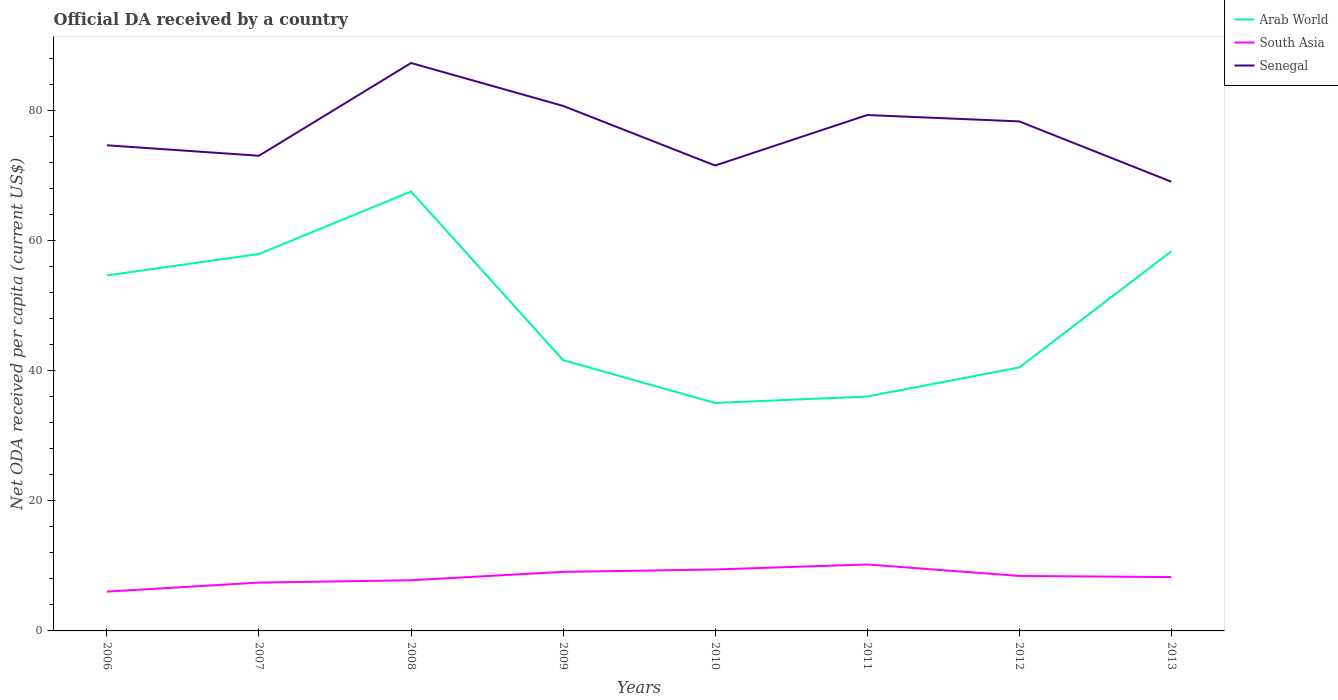How many different coloured lines are there?
Give a very brief answer. 3. Does the line corresponding to Senegal intersect with the line corresponding to Arab World?
Your answer should be compact. No. Across all years, what is the maximum ODA received in in Senegal?
Provide a succinct answer. 69.11. In which year was the ODA received in in Senegal maximum?
Keep it short and to the point. 2013. What is the total ODA received in in South Asia in the graph?
Ensure brevity in your answer.  -3.04. What is the difference between the highest and the second highest ODA received in in Arab World?
Make the answer very short. 32.53. Is the ODA received in in Arab World strictly greater than the ODA received in in South Asia over the years?
Provide a short and direct response. No. How many lines are there?
Your answer should be very brief. 3. How many years are there in the graph?
Offer a very short reply. 8. What is the difference between two consecutive major ticks on the Y-axis?
Offer a very short reply. 20. Does the graph contain grids?
Ensure brevity in your answer.  No. Where does the legend appear in the graph?
Keep it short and to the point. Top right. How many legend labels are there?
Your response must be concise. 3. What is the title of the graph?
Provide a short and direct response. Official DA received by a country. Does "Morocco" appear as one of the legend labels in the graph?
Your answer should be very brief. No. What is the label or title of the Y-axis?
Give a very brief answer. Net ODA received per capita (current US$). What is the Net ODA received per capita (current US$) in Arab World in 2006?
Give a very brief answer. 54.7. What is the Net ODA received per capita (current US$) in South Asia in 2006?
Your answer should be very brief. 6.05. What is the Net ODA received per capita (current US$) of Senegal in 2006?
Your answer should be very brief. 74.71. What is the Net ODA received per capita (current US$) of Arab World in 2007?
Provide a short and direct response. 57.98. What is the Net ODA received per capita (current US$) in South Asia in 2007?
Give a very brief answer. 7.43. What is the Net ODA received per capita (current US$) in Senegal in 2007?
Offer a very short reply. 73.1. What is the Net ODA received per capita (current US$) in Arab World in 2008?
Your answer should be very brief. 67.6. What is the Net ODA received per capita (current US$) of South Asia in 2008?
Make the answer very short. 7.8. What is the Net ODA received per capita (current US$) of Senegal in 2008?
Your response must be concise. 87.37. What is the Net ODA received per capita (current US$) in Arab World in 2009?
Provide a short and direct response. 41.66. What is the Net ODA received per capita (current US$) in South Asia in 2009?
Your answer should be very brief. 9.09. What is the Net ODA received per capita (current US$) of Senegal in 2009?
Give a very brief answer. 80.77. What is the Net ODA received per capita (current US$) in Arab World in 2010?
Provide a succinct answer. 35.07. What is the Net ODA received per capita (current US$) in South Asia in 2010?
Offer a very short reply. 9.45. What is the Net ODA received per capita (current US$) in Senegal in 2010?
Provide a short and direct response. 71.6. What is the Net ODA received per capita (current US$) of Arab World in 2011?
Give a very brief answer. 36.06. What is the Net ODA received per capita (current US$) in South Asia in 2011?
Your answer should be compact. 10.22. What is the Net ODA received per capita (current US$) of Senegal in 2011?
Your answer should be compact. 79.37. What is the Net ODA received per capita (current US$) of Arab World in 2012?
Provide a succinct answer. 40.53. What is the Net ODA received per capita (current US$) of South Asia in 2012?
Your answer should be compact. 8.46. What is the Net ODA received per capita (current US$) of Senegal in 2012?
Provide a succinct answer. 78.39. What is the Net ODA received per capita (current US$) of Arab World in 2013?
Offer a terse response. 58.39. What is the Net ODA received per capita (current US$) in South Asia in 2013?
Give a very brief answer. 8.28. What is the Net ODA received per capita (current US$) in Senegal in 2013?
Your response must be concise. 69.11. Across all years, what is the maximum Net ODA received per capita (current US$) of Arab World?
Ensure brevity in your answer.  67.6. Across all years, what is the maximum Net ODA received per capita (current US$) in South Asia?
Offer a very short reply. 10.22. Across all years, what is the maximum Net ODA received per capita (current US$) in Senegal?
Keep it short and to the point. 87.37. Across all years, what is the minimum Net ODA received per capita (current US$) of Arab World?
Your answer should be very brief. 35.07. Across all years, what is the minimum Net ODA received per capita (current US$) of South Asia?
Your answer should be very brief. 6.05. Across all years, what is the minimum Net ODA received per capita (current US$) of Senegal?
Your answer should be compact. 69.11. What is the total Net ODA received per capita (current US$) of Arab World in the graph?
Keep it short and to the point. 392. What is the total Net ODA received per capita (current US$) of South Asia in the graph?
Ensure brevity in your answer.  66.78. What is the total Net ODA received per capita (current US$) of Senegal in the graph?
Offer a terse response. 614.42. What is the difference between the Net ODA received per capita (current US$) in Arab World in 2006 and that in 2007?
Give a very brief answer. -3.29. What is the difference between the Net ODA received per capita (current US$) of South Asia in 2006 and that in 2007?
Your response must be concise. -1.39. What is the difference between the Net ODA received per capita (current US$) in Senegal in 2006 and that in 2007?
Offer a very short reply. 1.61. What is the difference between the Net ODA received per capita (current US$) in Arab World in 2006 and that in 2008?
Make the answer very short. -12.9. What is the difference between the Net ODA received per capita (current US$) in South Asia in 2006 and that in 2008?
Your response must be concise. -1.75. What is the difference between the Net ODA received per capita (current US$) of Senegal in 2006 and that in 2008?
Your response must be concise. -12.66. What is the difference between the Net ODA received per capita (current US$) in Arab World in 2006 and that in 2009?
Your answer should be very brief. 13.04. What is the difference between the Net ODA received per capita (current US$) of South Asia in 2006 and that in 2009?
Your answer should be very brief. -3.04. What is the difference between the Net ODA received per capita (current US$) in Senegal in 2006 and that in 2009?
Your answer should be compact. -6.06. What is the difference between the Net ODA received per capita (current US$) in Arab World in 2006 and that in 2010?
Make the answer very short. 19.63. What is the difference between the Net ODA received per capita (current US$) of South Asia in 2006 and that in 2010?
Make the answer very short. -3.4. What is the difference between the Net ODA received per capita (current US$) in Senegal in 2006 and that in 2010?
Offer a very short reply. 3.11. What is the difference between the Net ODA received per capita (current US$) of Arab World in 2006 and that in 2011?
Provide a succinct answer. 18.64. What is the difference between the Net ODA received per capita (current US$) of South Asia in 2006 and that in 2011?
Ensure brevity in your answer.  -4.17. What is the difference between the Net ODA received per capita (current US$) of Senegal in 2006 and that in 2011?
Your answer should be very brief. -4.65. What is the difference between the Net ODA received per capita (current US$) in Arab World in 2006 and that in 2012?
Provide a succinct answer. 14.16. What is the difference between the Net ODA received per capita (current US$) of South Asia in 2006 and that in 2012?
Provide a short and direct response. -2.41. What is the difference between the Net ODA received per capita (current US$) of Senegal in 2006 and that in 2012?
Offer a terse response. -3.68. What is the difference between the Net ODA received per capita (current US$) in Arab World in 2006 and that in 2013?
Make the answer very short. -3.7. What is the difference between the Net ODA received per capita (current US$) in South Asia in 2006 and that in 2013?
Offer a very short reply. -2.24. What is the difference between the Net ODA received per capita (current US$) in Senegal in 2006 and that in 2013?
Your answer should be compact. 5.6. What is the difference between the Net ODA received per capita (current US$) of Arab World in 2007 and that in 2008?
Provide a succinct answer. -9.61. What is the difference between the Net ODA received per capita (current US$) in South Asia in 2007 and that in 2008?
Offer a very short reply. -0.36. What is the difference between the Net ODA received per capita (current US$) in Senegal in 2007 and that in 2008?
Offer a very short reply. -14.27. What is the difference between the Net ODA received per capita (current US$) of Arab World in 2007 and that in 2009?
Keep it short and to the point. 16.32. What is the difference between the Net ODA received per capita (current US$) of South Asia in 2007 and that in 2009?
Keep it short and to the point. -1.65. What is the difference between the Net ODA received per capita (current US$) in Senegal in 2007 and that in 2009?
Make the answer very short. -7.67. What is the difference between the Net ODA received per capita (current US$) in Arab World in 2007 and that in 2010?
Give a very brief answer. 22.91. What is the difference between the Net ODA received per capita (current US$) of South Asia in 2007 and that in 2010?
Give a very brief answer. -2.02. What is the difference between the Net ODA received per capita (current US$) of Senegal in 2007 and that in 2010?
Your response must be concise. 1.5. What is the difference between the Net ODA received per capita (current US$) in Arab World in 2007 and that in 2011?
Your response must be concise. 21.93. What is the difference between the Net ODA received per capita (current US$) of South Asia in 2007 and that in 2011?
Provide a short and direct response. -2.79. What is the difference between the Net ODA received per capita (current US$) of Senegal in 2007 and that in 2011?
Give a very brief answer. -6.26. What is the difference between the Net ODA received per capita (current US$) of Arab World in 2007 and that in 2012?
Offer a terse response. 17.45. What is the difference between the Net ODA received per capita (current US$) in South Asia in 2007 and that in 2012?
Provide a succinct answer. -1.03. What is the difference between the Net ODA received per capita (current US$) of Senegal in 2007 and that in 2012?
Give a very brief answer. -5.28. What is the difference between the Net ODA received per capita (current US$) in Arab World in 2007 and that in 2013?
Your answer should be compact. -0.41. What is the difference between the Net ODA received per capita (current US$) of South Asia in 2007 and that in 2013?
Make the answer very short. -0.85. What is the difference between the Net ODA received per capita (current US$) of Senegal in 2007 and that in 2013?
Provide a short and direct response. 3.99. What is the difference between the Net ODA received per capita (current US$) in Arab World in 2008 and that in 2009?
Give a very brief answer. 25.94. What is the difference between the Net ODA received per capita (current US$) of South Asia in 2008 and that in 2009?
Your answer should be very brief. -1.29. What is the difference between the Net ODA received per capita (current US$) of Senegal in 2008 and that in 2009?
Your response must be concise. 6.6. What is the difference between the Net ODA received per capita (current US$) in Arab World in 2008 and that in 2010?
Keep it short and to the point. 32.53. What is the difference between the Net ODA received per capita (current US$) of South Asia in 2008 and that in 2010?
Your response must be concise. -1.66. What is the difference between the Net ODA received per capita (current US$) in Senegal in 2008 and that in 2010?
Give a very brief answer. 15.77. What is the difference between the Net ODA received per capita (current US$) in Arab World in 2008 and that in 2011?
Ensure brevity in your answer.  31.54. What is the difference between the Net ODA received per capita (current US$) of South Asia in 2008 and that in 2011?
Your response must be concise. -2.43. What is the difference between the Net ODA received per capita (current US$) in Senegal in 2008 and that in 2011?
Ensure brevity in your answer.  8.01. What is the difference between the Net ODA received per capita (current US$) of Arab World in 2008 and that in 2012?
Your answer should be very brief. 27.07. What is the difference between the Net ODA received per capita (current US$) of South Asia in 2008 and that in 2012?
Your answer should be compact. -0.66. What is the difference between the Net ODA received per capita (current US$) in Senegal in 2008 and that in 2012?
Your response must be concise. 8.98. What is the difference between the Net ODA received per capita (current US$) in Arab World in 2008 and that in 2013?
Your response must be concise. 9.2. What is the difference between the Net ODA received per capita (current US$) in South Asia in 2008 and that in 2013?
Ensure brevity in your answer.  -0.49. What is the difference between the Net ODA received per capita (current US$) of Senegal in 2008 and that in 2013?
Offer a very short reply. 18.26. What is the difference between the Net ODA received per capita (current US$) in Arab World in 2009 and that in 2010?
Offer a very short reply. 6.59. What is the difference between the Net ODA received per capita (current US$) of South Asia in 2009 and that in 2010?
Your answer should be very brief. -0.37. What is the difference between the Net ODA received per capita (current US$) in Senegal in 2009 and that in 2010?
Make the answer very short. 9.17. What is the difference between the Net ODA received per capita (current US$) of Arab World in 2009 and that in 2011?
Your answer should be compact. 5.6. What is the difference between the Net ODA received per capita (current US$) of South Asia in 2009 and that in 2011?
Offer a terse response. -1.14. What is the difference between the Net ODA received per capita (current US$) in Senegal in 2009 and that in 2011?
Your answer should be very brief. 1.41. What is the difference between the Net ODA received per capita (current US$) in Arab World in 2009 and that in 2012?
Give a very brief answer. 1.13. What is the difference between the Net ODA received per capita (current US$) in South Asia in 2009 and that in 2012?
Your answer should be compact. 0.62. What is the difference between the Net ODA received per capita (current US$) of Senegal in 2009 and that in 2012?
Ensure brevity in your answer.  2.38. What is the difference between the Net ODA received per capita (current US$) of Arab World in 2009 and that in 2013?
Offer a terse response. -16.73. What is the difference between the Net ODA received per capita (current US$) of South Asia in 2009 and that in 2013?
Provide a short and direct response. 0.8. What is the difference between the Net ODA received per capita (current US$) of Senegal in 2009 and that in 2013?
Offer a terse response. 11.66. What is the difference between the Net ODA received per capita (current US$) of Arab World in 2010 and that in 2011?
Provide a short and direct response. -0.99. What is the difference between the Net ODA received per capita (current US$) in South Asia in 2010 and that in 2011?
Keep it short and to the point. -0.77. What is the difference between the Net ODA received per capita (current US$) of Senegal in 2010 and that in 2011?
Your answer should be very brief. -7.77. What is the difference between the Net ODA received per capita (current US$) in Arab World in 2010 and that in 2012?
Ensure brevity in your answer.  -5.46. What is the difference between the Net ODA received per capita (current US$) of South Asia in 2010 and that in 2012?
Give a very brief answer. 0.99. What is the difference between the Net ODA received per capita (current US$) of Senegal in 2010 and that in 2012?
Give a very brief answer. -6.79. What is the difference between the Net ODA received per capita (current US$) of Arab World in 2010 and that in 2013?
Make the answer very short. -23.32. What is the difference between the Net ODA received per capita (current US$) of South Asia in 2010 and that in 2013?
Make the answer very short. 1.17. What is the difference between the Net ODA received per capita (current US$) of Senegal in 2010 and that in 2013?
Offer a very short reply. 2.49. What is the difference between the Net ODA received per capita (current US$) in Arab World in 2011 and that in 2012?
Your answer should be very brief. -4.48. What is the difference between the Net ODA received per capita (current US$) of South Asia in 2011 and that in 2012?
Offer a terse response. 1.76. What is the difference between the Net ODA received per capita (current US$) in Senegal in 2011 and that in 2012?
Your answer should be compact. 0.98. What is the difference between the Net ODA received per capita (current US$) in Arab World in 2011 and that in 2013?
Your response must be concise. -22.34. What is the difference between the Net ODA received per capita (current US$) in South Asia in 2011 and that in 2013?
Provide a succinct answer. 1.94. What is the difference between the Net ODA received per capita (current US$) of Senegal in 2011 and that in 2013?
Your response must be concise. 10.25. What is the difference between the Net ODA received per capita (current US$) in Arab World in 2012 and that in 2013?
Provide a short and direct response. -17.86. What is the difference between the Net ODA received per capita (current US$) in South Asia in 2012 and that in 2013?
Your answer should be compact. 0.18. What is the difference between the Net ODA received per capita (current US$) of Senegal in 2012 and that in 2013?
Keep it short and to the point. 9.28. What is the difference between the Net ODA received per capita (current US$) of Arab World in 2006 and the Net ODA received per capita (current US$) of South Asia in 2007?
Provide a short and direct response. 47.26. What is the difference between the Net ODA received per capita (current US$) of Arab World in 2006 and the Net ODA received per capita (current US$) of Senegal in 2007?
Make the answer very short. -18.41. What is the difference between the Net ODA received per capita (current US$) of South Asia in 2006 and the Net ODA received per capita (current US$) of Senegal in 2007?
Make the answer very short. -67.06. What is the difference between the Net ODA received per capita (current US$) in Arab World in 2006 and the Net ODA received per capita (current US$) in South Asia in 2008?
Offer a very short reply. 46.9. What is the difference between the Net ODA received per capita (current US$) of Arab World in 2006 and the Net ODA received per capita (current US$) of Senegal in 2008?
Ensure brevity in your answer.  -32.67. What is the difference between the Net ODA received per capita (current US$) of South Asia in 2006 and the Net ODA received per capita (current US$) of Senegal in 2008?
Provide a succinct answer. -81.32. What is the difference between the Net ODA received per capita (current US$) of Arab World in 2006 and the Net ODA received per capita (current US$) of South Asia in 2009?
Offer a terse response. 45.61. What is the difference between the Net ODA received per capita (current US$) of Arab World in 2006 and the Net ODA received per capita (current US$) of Senegal in 2009?
Your answer should be compact. -26.07. What is the difference between the Net ODA received per capita (current US$) of South Asia in 2006 and the Net ODA received per capita (current US$) of Senegal in 2009?
Offer a terse response. -74.72. What is the difference between the Net ODA received per capita (current US$) of Arab World in 2006 and the Net ODA received per capita (current US$) of South Asia in 2010?
Ensure brevity in your answer.  45.24. What is the difference between the Net ODA received per capita (current US$) of Arab World in 2006 and the Net ODA received per capita (current US$) of Senegal in 2010?
Provide a succinct answer. -16.9. What is the difference between the Net ODA received per capita (current US$) of South Asia in 2006 and the Net ODA received per capita (current US$) of Senegal in 2010?
Your answer should be very brief. -65.55. What is the difference between the Net ODA received per capita (current US$) in Arab World in 2006 and the Net ODA received per capita (current US$) in South Asia in 2011?
Make the answer very short. 44.48. What is the difference between the Net ODA received per capita (current US$) of Arab World in 2006 and the Net ODA received per capita (current US$) of Senegal in 2011?
Provide a short and direct response. -24.67. What is the difference between the Net ODA received per capita (current US$) in South Asia in 2006 and the Net ODA received per capita (current US$) in Senegal in 2011?
Provide a short and direct response. -73.32. What is the difference between the Net ODA received per capita (current US$) of Arab World in 2006 and the Net ODA received per capita (current US$) of South Asia in 2012?
Provide a short and direct response. 46.24. What is the difference between the Net ODA received per capita (current US$) of Arab World in 2006 and the Net ODA received per capita (current US$) of Senegal in 2012?
Offer a terse response. -23.69. What is the difference between the Net ODA received per capita (current US$) of South Asia in 2006 and the Net ODA received per capita (current US$) of Senegal in 2012?
Your response must be concise. -72.34. What is the difference between the Net ODA received per capita (current US$) of Arab World in 2006 and the Net ODA received per capita (current US$) of South Asia in 2013?
Ensure brevity in your answer.  46.41. What is the difference between the Net ODA received per capita (current US$) in Arab World in 2006 and the Net ODA received per capita (current US$) in Senegal in 2013?
Offer a terse response. -14.41. What is the difference between the Net ODA received per capita (current US$) of South Asia in 2006 and the Net ODA received per capita (current US$) of Senegal in 2013?
Ensure brevity in your answer.  -63.06. What is the difference between the Net ODA received per capita (current US$) in Arab World in 2007 and the Net ODA received per capita (current US$) in South Asia in 2008?
Your answer should be very brief. 50.19. What is the difference between the Net ODA received per capita (current US$) of Arab World in 2007 and the Net ODA received per capita (current US$) of Senegal in 2008?
Make the answer very short. -29.39. What is the difference between the Net ODA received per capita (current US$) in South Asia in 2007 and the Net ODA received per capita (current US$) in Senegal in 2008?
Offer a terse response. -79.94. What is the difference between the Net ODA received per capita (current US$) in Arab World in 2007 and the Net ODA received per capita (current US$) in South Asia in 2009?
Ensure brevity in your answer.  48.9. What is the difference between the Net ODA received per capita (current US$) in Arab World in 2007 and the Net ODA received per capita (current US$) in Senegal in 2009?
Provide a succinct answer. -22.79. What is the difference between the Net ODA received per capita (current US$) of South Asia in 2007 and the Net ODA received per capita (current US$) of Senegal in 2009?
Your answer should be very brief. -73.34. What is the difference between the Net ODA received per capita (current US$) in Arab World in 2007 and the Net ODA received per capita (current US$) in South Asia in 2010?
Provide a succinct answer. 48.53. What is the difference between the Net ODA received per capita (current US$) of Arab World in 2007 and the Net ODA received per capita (current US$) of Senegal in 2010?
Keep it short and to the point. -13.61. What is the difference between the Net ODA received per capita (current US$) in South Asia in 2007 and the Net ODA received per capita (current US$) in Senegal in 2010?
Your answer should be very brief. -64.16. What is the difference between the Net ODA received per capita (current US$) in Arab World in 2007 and the Net ODA received per capita (current US$) in South Asia in 2011?
Ensure brevity in your answer.  47.76. What is the difference between the Net ODA received per capita (current US$) in Arab World in 2007 and the Net ODA received per capita (current US$) in Senegal in 2011?
Ensure brevity in your answer.  -21.38. What is the difference between the Net ODA received per capita (current US$) of South Asia in 2007 and the Net ODA received per capita (current US$) of Senegal in 2011?
Ensure brevity in your answer.  -71.93. What is the difference between the Net ODA received per capita (current US$) of Arab World in 2007 and the Net ODA received per capita (current US$) of South Asia in 2012?
Keep it short and to the point. 49.52. What is the difference between the Net ODA received per capita (current US$) in Arab World in 2007 and the Net ODA received per capita (current US$) in Senegal in 2012?
Offer a very short reply. -20.4. What is the difference between the Net ODA received per capita (current US$) of South Asia in 2007 and the Net ODA received per capita (current US$) of Senegal in 2012?
Your answer should be very brief. -70.95. What is the difference between the Net ODA received per capita (current US$) of Arab World in 2007 and the Net ODA received per capita (current US$) of South Asia in 2013?
Ensure brevity in your answer.  49.7. What is the difference between the Net ODA received per capita (current US$) in Arab World in 2007 and the Net ODA received per capita (current US$) in Senegal in 2013?
Your response must be concise. -11.13. What is the difference between the Net ODA received per capita (current US$) of South Asia in 2007 and the Net ODA received per capita (current US$) of Senegal in 2013?
Your answer should be very brief. -61.68. What is the difference between the Net ODA received per capita (current US$) of Arab World in 2008 and the Net ODA received per capita (current US$) of South Asia in 2009?
Provide a succinct answer. 58.51. What is the difference between the Net ODA received per capita (current US$) of Arab World in 2008 and the Net ODA received per capita (current US$) of Senegal in 2009?
Your answer should be compact. -13.17. What is the difference between the Net ODA received per capita (current US$) in South Asia in 2008 and the Net ODA received per capita (current US$) in Senegal in 2009?
Provide a short and direct response. -72.97. What is the difference between the Net ODA received per capita (current US$) in Arab World in 2008 and the Net ODA received per capita (current US$) in South Asia in 2010?
Your response must be concise. 58.15. What is the difference between the Net ODA received per capita (current US$) in Arab World in 2008 and the Net ODA received per capita (current US$) in Senegal in 2010?
Keep it short and to the point. -4. What is the difference between the Net ODA received per capita (current US$) of South Asia in 2008 and the Net ODA received per capita (current US$) of Senegal in 2010?
Your response must be concise. -63.8. What is the difference between the Net ODA received per capita (current US$) of Arab World in 2008 and the Net ODA received per capita (current US$) of South Asia in 2011?
Offer a very short reply. 57.38. What is the difference between the Net ODA received per capita (current US$) of Arab World in 2008 and the Net ODA received per capita (current US$) of Senegal in 2011?
Your answer should be very brief. -11.77. What is the difference between the Net ODA received per capita (current US$) in South Asia in 2008 and the Net ODA received per capita (current US$) in Senegal in 2011?
Your answer should be compact. -71.57. What is the difference between the Net ODA received per capita (current US$) of Arab World in 2008 and the Net ODA received per capita (current US$) of South Asia in 2012?
Your response must be concise. 59.14. What is the difference between the Net ODA received per capita (current US$) in Arab World in 2008 and the Net ODA received per capita (current US$) in Senegal in 2012?
Your answer should be very brief. -10.79. What is the difference between the Net ODA received per capita (current US$) of South Asia in 2008 and the Net ODA received per capita (current US$) of Senegal in 2012?
Provide a succinct answer. -70.59. What is the difference between the Net ODA received per capita (current US$) of Arab World in 2008 and the Net ODA received per capita (current US$) of South Asia in 2013?
Offer a very short reply. 59.32. What is the difference between the Net ODA received per capita (current US$) of Arab World in 2008 and the Net ODA received per capita (current US$) of Senegal in 2013?
Offer a terse response. -1.51. What is the difference between the Net ODA received per capita (current US$) in South Asia in 2008 and the Net ODA received per capita (current US$) in Senegal in 2013?
Provide a short and direct response. -61.31. What is the difference between the Net ODA received per capita (current US$) of Arab World in 2009 and the Net ODA received per capita (current US$) of South Asia in 2010?
Keep it short and to the point. 32.21. What is the difference between the Net ODA received per capita (current US$) of Arab World in 2009 and the Net ODA received per capita (current US$) of Senegal in 2010?
Give a very brief answer. -29.94. What is the difference between the Net ODA received per capita (current US$) in South Asia in 2009 and the Net ODA received per capita (current US$) in Senegal in 2010?
Ensure brevity in your answer.  -62.51. What is the difference between the Net ODA received per capita (current US$) in Arab World in 2009 and the Net ODA received per capita (current US$) in South Asia in 2011?
Provide a short and direct response. 31.44. What is the difference between the Net ODA received per capita (current US$) of Arab World in 2009 and the Net ODA received per capita (current US$) of Senegal in 2011?
Offer a terse response. -37.7. What is the difference between the Net ODA received per capita (current US$) in South Asia in 2009 and the Net ODA received per capita (current US$) in Senegal in 2011?
Give a very brief answer. -70.28. What is the difference between the Net ODA received per capita (current US$) in Arab World in 2009 and the Net ODA received per capita (current US$) in South Asia in 2012?
Offer a very short reply. 33.2. What is the difference between the Net ODA received per capita (current US$) in Arab World in 2009 and the Net ODA received per capita (current US$) in Senegal in 2012?
Your answer should be compact. -36.73. What is the difference between the Net ODA received per capita (current US$) in South Asia in 2009 and the Net ODA received per capita (current US$) in Senegal in 2012?
Provide a succinct answer. -69.3. What is the difference between the Net ODA received per capita (current US$) of Arab World in 2009 and the Net ODA received per capita (current US$) of South Asia in 2013?
Provide a short and direct response. 33.38. What is the difference between the Net ODA received per capita (current US$) in Arab World in 2009 and the Net ODA received per capita (current US$) in Senegal in 2013?
Make the answer very short. -27.45. What is the difference between the Net ODA received per capita (current US$) in South Asia in 2009 and the Net ODA received per capita (current US$) in Senegal in 2013?
Offer a terse response. -60.02. What is the difference between the Net ODA received per capita (current US$) in Arab World in 2010 and the Net ODA received per capita (current US$) in South Asia in 2011?
Your response must be concise. 24.85. What is the difference between the Net ODA received per capita (current US$) of Arab World in 2010 and the Net ODA received per capita (current US$) of Senegal in 2011?
Give a very brief answer. -44.29. What is the difference between the Net ODA received per capita (current US$) of South Asia in 2010 and the Net ODA received per capita (current US$) of Senegal in 2011?
Offer a terse response. -69.91. What is the difference between the Net ODA received per capita (current US$) in Arab World in 2010 and the Net ODA received per capita (current US$) in South Asia in 2012?
Give a very brief answer. 26.61. What is the difference between the Net ODA received per capita (current US$) in Arab World in 2010 and the Net ODA received per capita (current US$) in Senegal in 2012?
Offer a terse response. -43.32. What is the difference between the Net ODA received per capita (current US$) of South Asia in 2010 and the Net ODA received per capita (current US$) of Senegal in 2012?
Your response must be concise. -68.93. What is the difference between the Net ODA received per capita (current US$) in Arab World in 2010 and the Net ODA received per capita (current US$) in South Asia in 2013?
Keep it short and to the point. 26.79. What is the difference between the Net ODA received per capita (current US$) of Arab World in 2010 and the Net ODA received per capita (current US$) of Senegal in 2013?
Give a very brief answer. -34.04. What is the difference between the Net ODA received per capita (current US$) of South Asia in 2010 and the Net ODA received per capita (current US$) of Senegal in 2013?
Keep it short and to the point. -59.66. What is the difference between the Net ODA received per capita (current US$) of Arab World in 2011 and the Net ODA received per capita (current US$) of South Asia in 2012?
Provide a short and direct response. 27.6. What is the difference between the Net ODA received per capita (current US$) in Arab World in 2011 and the Net ODA received per capita (current US$) in Senegal in 2012?
Provide a succinct answer. -42.33. What is the difference between the Net ODA received per capita (current US$) in South Asia in 2011 and the Net ODA received per capita (current US$) in Senegal in 2012?
Offer a very short reply. -68.16. What is the difference between the Net ODA received per capita (current US$) of Arab World in 2011 and the Net ODA received per capita (current US$) of South Asia in 2013?
Give a very brief answer. 27.77. What is the difference between the Net ODA received per capita (current US$) of Arab World in 2011 and the Net ODA received per capita (current US$) of Senegal in 2013?
Your response must be concise. -33.05. What is the difference between the Net ODA received per capita (current US$) in South Asia in 2011 and the Net ODA received per capita (current US$) in Senegal in 2013?
Ensure brevity in your answer.  -58.89. What is the difference between the Net ODA received per capita (current US$) in Arab World in 2012 and the Net ODA received per capita (current US$) in South Asia in 2013?
Keep it short and to the point. 32.25. What is the difference between the Net ODA received per capita (current US$) of Arab World in 2012 and the Net ODA received per capita (current US$) of Senegal in 2013?
Provide a short and direct response. -28.58. What is the difference between the Net ODA received per capita (current US$) of South Asia in 2012 and the Net ODA received per capita (current US$) of Senegal in 2013?
Your answer should be compact. -60.65. What is the average Net ODA received per capita (current US$) of Arab World per year?
Keep it short and to the point. 49. What is the average Net ODA received per capita (current US$) in South Asia per year?
Make the answer very short. 8.35. What is the average Net ODA received per capita (current US$) in Senegal per year?
Make the answer very short. 76.8. In the year 2006, what is the difference between the Net ODA received per capita (current US$) of Arab World and Net ODA received per capita (current US$) of South Asia?
Your response must be concise. 48.65. In the year 2006, what is the difference between the Net ODA received per capita (current US$) in Arab World and Net ODA received per capita (current US$) in Senegal?
Your response must be concise. -20.01. In the year 2006, what is the difference between the Net ODA received per capita (current US$) of South Asia and Net ODA received per capita (current US$) of Senegal?
Offer a very short reply. -68.66. In the year 2007, what is the difference between the Net ODA received per capita (current US$) of Arab World and Net ODA received per capita (current US$) of South Asia?
Provide a short and direct response. 50.55. In the year 2007, what is the difference between the Net ODA received per capita (current US$) in Arab World and Net ODA received per capita (current US$) in Senegal?
Give a very brief answer. -15.12. In the year 2007, what is the difference between the Net ODA received per capita (current US$) of South Asia and Net ODA received per capita (current US$) of Senegal?
Provide a succinct answer. -65.67. In the year 2008, what is the difference between the Net ODA received per capita (current US$) of Arab World and Net ODA received per capita (current US$) of South Asia?
Provide a succinct answer. 59.8. In the year 2008, what is the difference between the Net ODA received per capita (current US$) in Arab World and Net ODA received per capita (current US$) in Senegal?
Give a very brief answer. -19.77. In the year 2008, what is the difference between the Net ODA received per capita (current US$) of South Asia and Net ODA received per capita (current US$) of Senegal?
Keep it short and to the point. -79.57. In the year 2009, what is the difference between the Net ODA received per capita (current US$) in Arab World and Net ODA received per capita (current US$) in South Asia?
Offer a very short reply. 32.58. In the year 2009, what is the difference between the Net ODA received per capita (current US$) of Arab World and Net ODA received per capita (current US$) of Senegal?
Provide a succinct answer. -39.11. In the year 2009, what is the difference between the Net ODA received per capita (current US$) in South Asia and Net ODA received per capita (current US$) in Senegal?
Your response must be concise. -71.69. In the year 2010, what is the difference between the Net ODA received per capita (current US$) of Arab World and Net ODA received per capita (current US$) of South Asia?
Your response must be concise. 25.62. In the year 2010, what is the difference between the Net ODA received per capita (current US$) in Arab World and Net ODA received per capita (current US$) in Senegal?
Offer a very short reply. -36.53. In the year 2010, what is the difference between the Net ODA received per capita (current US$) in South Asia and Net ODA received per capita (current US$) in Senegal?
Make the answer very short. -62.15. In the year 2011, what is the difference between the Net ODA received per capita (current US$) in Arab World and Net ODA received per capita (current US$) in South Asia?
Offer a very short reply. 25.84. In the year 2011, what is the difference between the Net ODA received per capita (current US$) of Arab World and Net ODA received per capita (current US$) of Senegal?
Your answer should be compact. -43.31. In the year 2011, what is the difference between the Net ODA received per capita (current US$) in South Asia and Net ODA received per capita (current US$) in Senegal?
Ensure brevity in your answer.  -69.14. In the year 2012, what is the difference between the Net ODA received per capita (current US$) of Arab World and Net ODA received per capita (current US$) of South Asia?
Make the answer very short. 32.07. In the year 2012, what is the difference between the Net ODA received per capita (current US$) in Arab World and Net ODA received per capita (current US$) in Senegal?
Make the answer very short. -37.85. In the year 2012, what is the difference between the Net ODA received per capita (current US$) of South Asia and Net ODA received per capita (current US$) of Senegal?
Your answer should be compact. -69.93. In the year 2013, what is the difference between the Net ODA received per capita (current US$) of Arab World and Net ODA received per capita (current US$) of South Asia?
Offer a very short reply. 50.11. In the year 2013, what is the difference between the Net ODA received per capita (current US$) of Arab World and Net ODA received per capita (current US$) of Senegal?
Provide a succinct answer. -10.72. In the year 2013, what is the difference between the Net ODA received per capita (current US$) of South Asia and Net ODA received per capita (current US$) of Senegal?
Provide a short and direct response. -60.83. What is the ratio of the Net ODA received per capita (current US$) of Arab World in 2006 to that in 2007?
Your response must be concise. 0.94. What is the ratio of the Net ODA received per capita (current US$) in South Asia in 2006 to that in 2007?
Provide a succinct answer. 0.81. What is the ratio of the Net ODA received per capita (current US$) of Senegal in 2006 to that in 2007?
Your answer should be very brief. 1.02. What is the ratio of the Net ODA received per capita (current US$) of Arab World in 2006 to that in 2008?
Keep it short and to the point. 0.81. What is the ratio of the Net ODA received per capita (current US$) in South Asia in 2006 to that in 2008?
Your answer should be very brief. 0.78. What is the ratio of the Net ODA received per capita (current US$) in Senegal in 2006 to that in 2008?
Provide a succinct answer. 0.86. What is the ratio of the Net ODA received per capita (current US$) of Arab World in 2006 to that in 2009?
Provide a short and direct response. 1.31. What is the ratio of the Net ODA received per capita (current US$) of South Asia in 2006 to that in 2009?
Offer a terse response. 0.67. What is the ratio of the Net ODA received per capita (current US$) in Senegal in 2006 to that in 2009?
Offer a very short reply. 0.93. What is the ratio of the Net ODA received per capita (current US$) of Arab World in 2006 to that in 2010?
Offer a terse response. 1.56. What is the ratio of the Net ODA received per capita (current US$) in South Asia in 2006 to that in 2010?
Ensure brevity in your answer.  0.64. What is the ratio of the Net ODA received per capita (current US$) in Senegal in 2006 to that in 2010?
Offer a very short reply. 1.04. What is the ratio of the Net ODA received per capita (current US$) in Arab World in 2006 to that in 2011?
Keep it short and to the point. 1.52. What is the ratio of the Net ODA received per capita (current US$) in South Asia in 2006 to that in 2011?
Offer a very short reply. 0.59. What is the ratio of the Net ODA received per capita (current US$) in Senegal in 2006 to that in 2011?
Provide a succinct answer. 0.94. What is the ratio of the Net ODA received per capita (current US$) in Arab World in 2006 to that in 2012?
Your response must be concise. 1.35. What is the ratio of the Net ODA received per capita (current US$) in South Asia in 2006 to that in 2012?
Your answer should be compact. 0.71. What is the ratio of the Net ODA received per capita (current US$) in Senegal in 2006 to that in 2012?
Ensure brevity in your answer.  0.95. What is the ratio of the Net ODA received per capita (current US$) in Arab World in 2006 to that in 2013?
Keep it short and to the point. 0.94. What is the ratio of the Net ODA received per capita (current US$) of South Asia in 2006 to that in 2013?
Provide a succinct answer. 0.73. What is the ratio of the Net ODA received per capita (current US$) in Senegal in 2006 to that in 2013?
Provide a short and direct response. 1.08. What is the ratio of the Net ODA received per capita (current US$) of Arab World in 2007 to that in 2008?
Provide a short and direct response. 0.86. What is the ratio of the Net ODA received per capita (current US$) in South Asia in 2007 to that in 2008?
Your response must be concise. 0.95. What is the ratio of the Net ODA received per capita (current US$) in Senegal in 2007 to that in 2008?
Offer a very short reply. 0.84. What is the ratio of the Net ODA received per capita (current US$) of Arab World in 2007 to that in 2009?
Ensure brevity in your answer.  1.39. What is the ratio of the Net ODA received per capita (current US$) in South Asia in 2007 to that in 2009?
Your answer should be very brief. 0.82. What is the ratio of the Net ODA received per capita (current US$) of Senegal in 2007 to that in 2009?
Offer a terse response. 0.91. What is the ratio of the Net ODA received per capita (current US$) in Arab World in 2007 to that in 2010?
Ensure brevity in your answer.  1.65. What is the ratio of the Net ODA received per capita (current US$) of South Asia in 2007 to that in 2010?
Provide a succinct answer. 0.79. What is the ratio of the Net ODA received per capita (current US$) in Arab World in 2007 to that in 2011?
Provide a succinct answer. 1.61. What is the ratio of the Net ODA received per capita (current US$) of South Asia in 2007 to that in 2011?
Your answer should be compact. 0.73. What is the ratio of the Net ODA received per capita (current US$) in Senegal in 2007 to that in 2011?
Provide a short and direct response. 0.92. What is the ratio of the Net ODA received per capita (current US$) in Arab World in 2007 to that in 2012?
Offer a terse response. 1.43. What is the ratio of the Net ODA received per capita (current US$) of South Asia in 2007 to that in 2012?
Keep it short and to the point. 0.88. What is the ratio of the Net ODA received per capita (current US$) in Senegal in 2007 to that in 2012?
Ensure brevity in your answer.  0.93. What is the ratio of the Net ODA received per capita (current US$) in South Asia in 2007 to that in 2013?
Offer a very short reply. 0.9. What is the ratio of the Net ODA received per capita (current US$) of Senegal in 2007 to that in 2013?
Make the answer very short. 1.06. What is the ratio of the Net ODA received per capita (current US$) of Arab World in 2008 to that in 2009?
Keep it short and to the point. 1.62. What is the ratio of the Net ODA received per capita (current US$) in South Asia in 2008 to that in 2009?
Your answer should be very brief. 0.86. What is the ratio of the Net ODA received per capita (current US$) of Senegal in 2008 to that in 2009?
Give a very brief answer. 1.08. What is the ratio of the Net ODA received per capita (current US$) of Arab World in 2008 to that in 2010?
Offer a very short reply. 1.93. What is the ratio of the Net ODA received per capita (current US$) of South Asia in 2008 to that in 2010?
Offer a terse response. 0.82. What is the ratio of the Net ODA received per capita (current US$) in Senegal in 2008 to that in 2010?
Provide a succinct answer. 1.22. What is the ratio of the Net ODA received per capita (current US$) in Arab World in 2008 to that in 2011?
Your answer should be compact. 1.87. What is the ratio of the Net ODA received per capita (current US$) in South Asia in 2008 to that in 2011?
Offer a very short reply. 0.76. What is the ratio of the Net ODA received per capita (current US$) in Senegal in 2008 to that in 2011?
Provide a succinct answer. 1.1. What is the ratio of the Net ODA received per capita (current US$) in Arab World in 2008 to that in 2012?
Provide a succinct answer. 1.67. What is the ratio of the Net ODA received per capita (current US$) of South Asia in 2008 to that in 2012?
Provide a short and direct response. 0.92. What is the ratio of the Net ODA received per capita (current US$) in Senegal in 2008 to that in 2012?
Ensure brevity in your answer.  1.11. What is the ratio of the Net ODA received per capita (current US$) in Arab World in 2008 to that in 2013?
Offer a terse response. 1.16. What is the ratio of the Net ODA received per capita (current US$) in South Asia in 2008 to that in 2013?
Provide a short and direct response. 0.94. What is the ratio of the Net ODA received per capita (current US$) of Senegal in 2008 to that in 2013?
Keep it short and to the point. 1.26. What is the ratio of the Net ODA received per capita (current US$) of Arab World in 2009 to that in 2010?
Your answer should be compact. 1.19. What is the ratio of the Net ODA received per capita (current US$) of South Asia in 2009 to that in 2010?
Your answer should be compact. 0.96. What is the ratio of the Net ODA received per capita (current US$) of Senegal in 2009 to that in 2010?
Your answer should be compact. 1.13. What is the ratio of the Net ODA received per capita (current US$) in Arab World in 2009 to that in 2011?
Your answer should be very brief. 1.16. What is the ratio of the Net ODA received per capita (current US$) in South Asia in 2009 to that in 2011?
Ensure brevity in your answer.  0.89. What is the ratio of the Net ODA received per capita (current US$) of Senegal in 2009 to that in 2011?
Provide a short and direct response. 1.02. What is the ratio of the Net ODA received per capita (current US$) in Arab World in 2009 to that in 2012?
Your response must be concise. 1.03. What is the ratio of the Net ODA received per capita (current US$) in South Asia in 2009 to that in 2012?
Provide a short and direct response. 1.07. What is the ratio of the Net ODA received per capita (current US$) of Senegal in 2009 to that in 2012?
Offer a very short reply. 1.03. What is the ratio of the Net ODA received per capita (current US$) of Arab World in 2009 to that in 2013?
Your response must be concise. 0.71. What is the ratio of the Net ODA received per capita (current US$) in South Asia in 2009 to that in 2013?
Provide a short and direct response. 1.1. What is the ratio of the Net ODA received per capita (current US$) in Senegal in 2009 to that in 2013?
Make the answer very short. 1.17. What is the ratio of the Net ODA received per capita (current US$) in Arab World in 2010 to that in 2011?
Your response must be concise. 0.97. What is the ratio of the Net ODA received per capita (current US$) of South Asia in 2010 to that in 2011?
Give a very brief answer. 0.92. What is the ratio of the Net ODA received per capita (current US$) in Senegal in 2010 to that in 2011?
Give a very brief answer. 0.9. What is the ratio of the Net ODA received per capita (current US$) of Arab World in 2010 to that in 2012?
Offer a very short reply. 0.87. What is the ratio of the Net ODA received per capita (current US$) in South Asia in 2010 to that in 2012?
Offer a very short reply. 1.12. What is the ratio of the Net ODA received per capita (current US$) in Senegal in 2010 to that in 2012?
Keep it short and to the point. 0.91. What is the ratio of the Net ODA received per capita (current US$) of Arab World in 2010 to that in 2013?
Keep it short and to the point. 0.6. What is the ratio of the Net ODA received per capita (current US$) in South Asia in 2010 to that in 2013?
Provide a short and direct response. 1.14. What is the ratio of the Net ODA received per capita (current US$) in Senegal in 2010 to that in 2013?
Provide a short and direct response. 1.04. What is the ratio of the Net ODA received per capita (current US$) of Arab World in 2011 to that in 2012?
Provide a short and direct response. 0.89. What is the ratio of the Net ODA received per capita (current US$) of South Asia in 2011 to that in 2012?
Provide a short and direct response. 1.21. What is the ratio of the Net ODA received per capita (current US$) in Senegal in 2011 to that in 2012?
Offer a very short reply. 1.01. What is the ratio of the Net ODA received per capita (current US$) in Arab World in 2011 to that in 2013?
Ensure brevity in your answer.  0.62. What is the ratio of the Net ODA received per capita (current US$) in South Asia in 2011 to that in 2013?
Provide a succinct answer. 1.23. What is the ratio of the Net ODA received per capita (current US$) of Senegal in 2011 to that in 2013?
Provide a short and direct response. 1.15. What is the ratio of the Net ODA received per capita (current US$) in Arab World in 2012 to that in 2013?
Ensure brevity in your answer.  0.69. What is the ratio of the Net ODA received per capita (current US$) in South Asia in 2012 to that in 2013?
Your answer should be very brief. 1.02. What is the ratio of the Net ODA received per capita (current US$) of Senegal in 2012 to that in 2013?
Your answer should be compact. 1.13. What is the difference between the highest and the second highest Net ODA received per capita (current US$) of Arab World?
Provide a short and direct response. 9.2. What is the difference between the highest and the second highest Net ODA received per capita (current US$) in South Asia?
Ensure brevity in your answer.  0.77. What is the difference between the highest and the second highest Net ODA received per capita (current US$) of Senegal?
Your answer should be compact. 6.6. What is the difference between the highest and the lowest Net ODA received per capita (current US$) in Arab World?
Make the answer very short. 32.53. What is the difference between the highest and the lowest Net ODA received per capita (current US$) in South Asia?
Your answer should be very brief. 4.17. What is the difference between the highest and the lowest Net ODA received per capita (current US$) of Senegal?
Offer a very short reply. 18.26. 